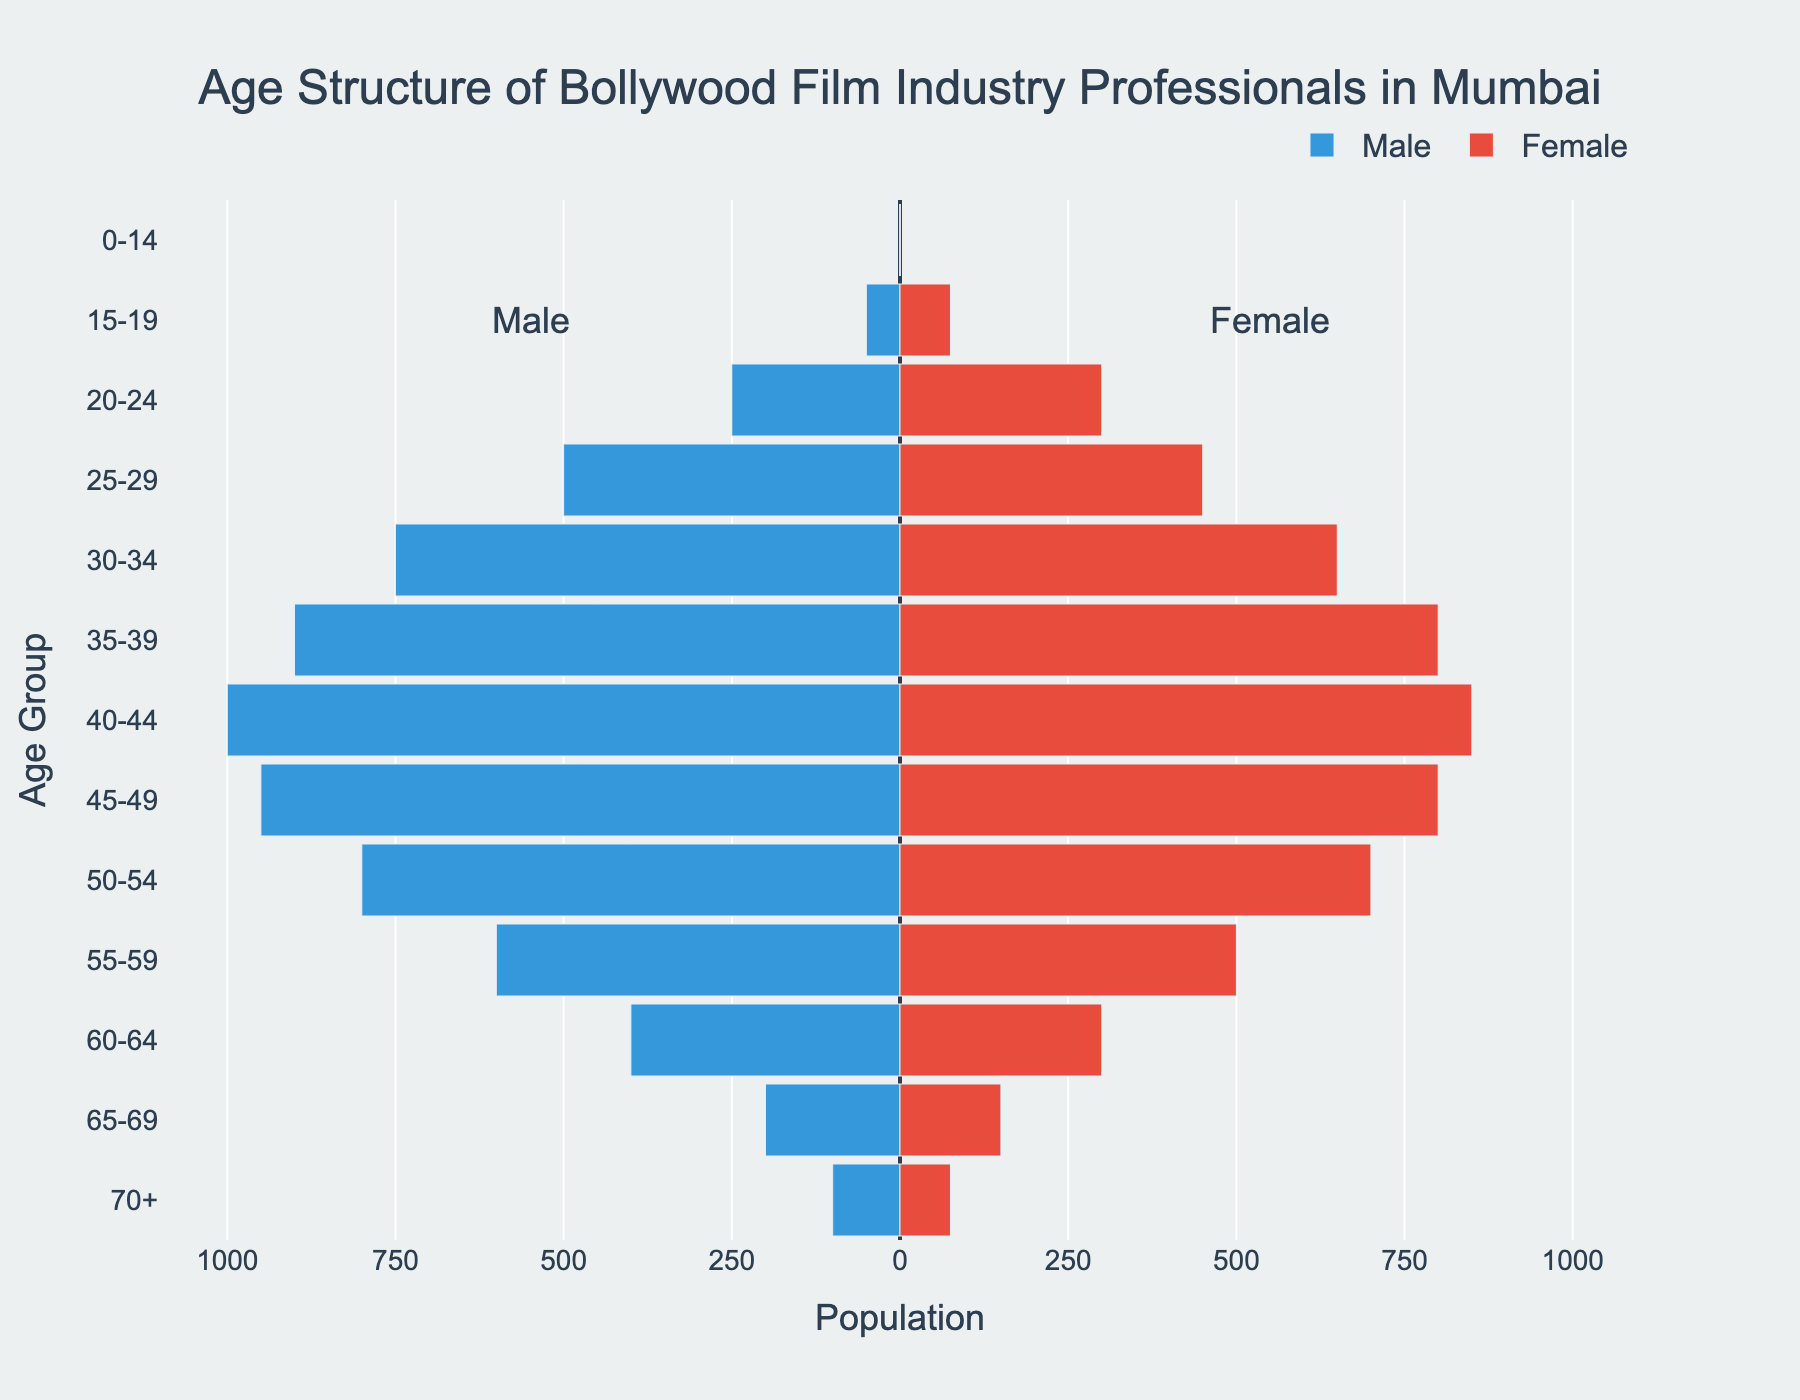What is the title of the plot? The title is usually at the top of a plot. In this case, it is "Age Structure of Bollywood Film Industry Professionals in Mumbai".
Answer: Age Structure of Bollywood Film Industry Professionals in Mumbai Which age group has the highest number of male professionals? By examining the lengths of the bars on the left side of the pyramid representing male professionals, the age group 40-44 has the longest bar indicating the highest value of 1000.
Answer: 40-44 What is the difference in the number of male and female professionals in the 30-34 age group? The number of male professionals in the 30-34 age group is 750, and the number of female professionals is 650. The difference is 750 - 650.
Answer: 100 Which gender has the higher representation in the 55-59 age group? By comparing the bars for the 55-59 age group, the male bar (left side) has a value of 600, while the female bar (right side) has a value of 500. The male professionals are higher in number.
Answer: Male What is the total number of female professionals aged 25-34? The age groups involved are 25-29 and 30-34. Add the values for females in these age groups: 450 (25-29) + 650 (30-34).
Answer: 1100 Which age group has the smallest combined number of male and female professionals? By adding the number of males and females in each age group, the smallest sum is found in the 0-14 age group as it has 0 male and 0 female professionals.
Answer: 0-14 How many more female professionals are there in the 20-24 age group compared to the male professionals in the same group? The number of female professionals in the 20-24 age group is 300, and the number of male professionals is 250. 300 - 250 gives the difference.
Answer: 50 In which age group does the number of female professionals exceed the number of male professionals, if any? By comparing the lengths of the bars for each age group, the age group 15-19 shows more female professionals (75) than male professionals (50).
Answer: 15-19 What is the average number of professionals (both genders combined) in the 40-44 age group? Add the number of males and females in the age group 40-44: 1000 (males) + 850 (females) = 1850. Then divide by 2 to get the average.
Answer: 925 